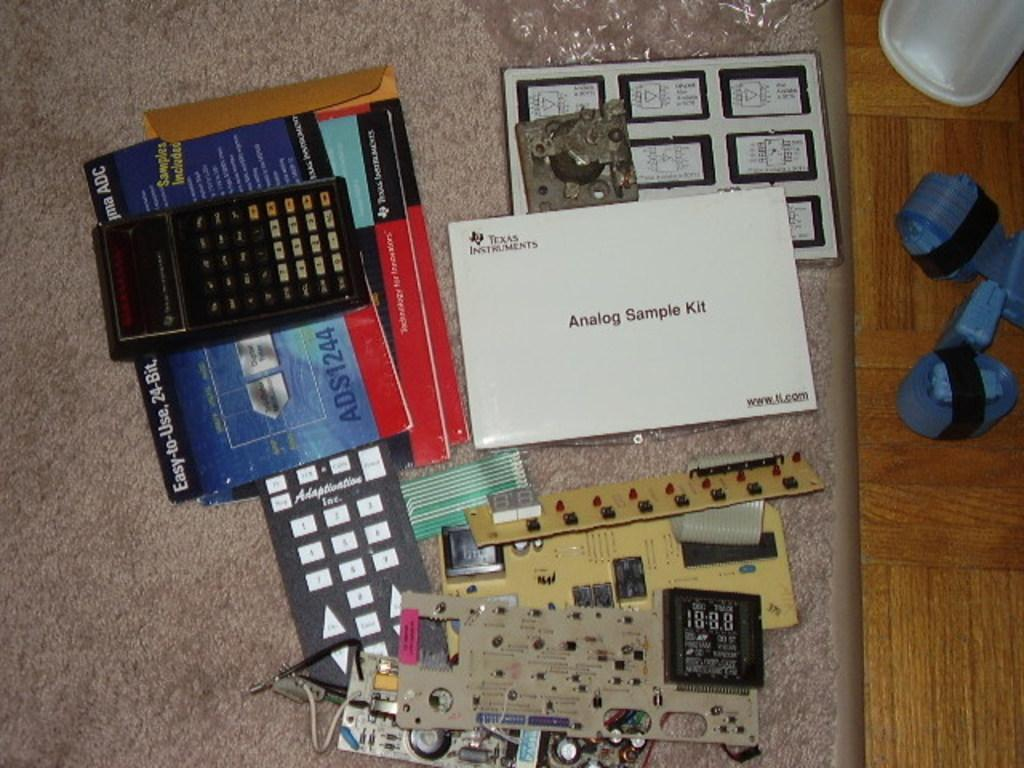<image>
Summarize the visual content of the image. Analog Sample Kit booklet from Texas Instruments with a www.ti.com website at the bottom. 